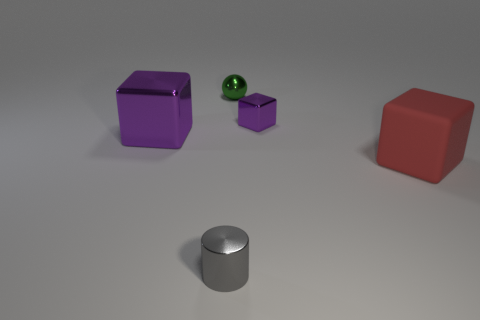Subtract all red blocks. Subtract all cyan spheres. How many blocks are left? 2 Add 2 large yellow metal cylinders. How many objects exist? 7 Subtract all blocks. How many objects are left? 2 Add 2 red things. How many red things are left? 3 Add 1 tiny metallic cubes. How many tiny metallic cubes exist? 2 Subtract 1 gray cylinders. How many objects are left? 4 Subtract all gray cylinders. Subtract all green objects. How many objects are left? 3 